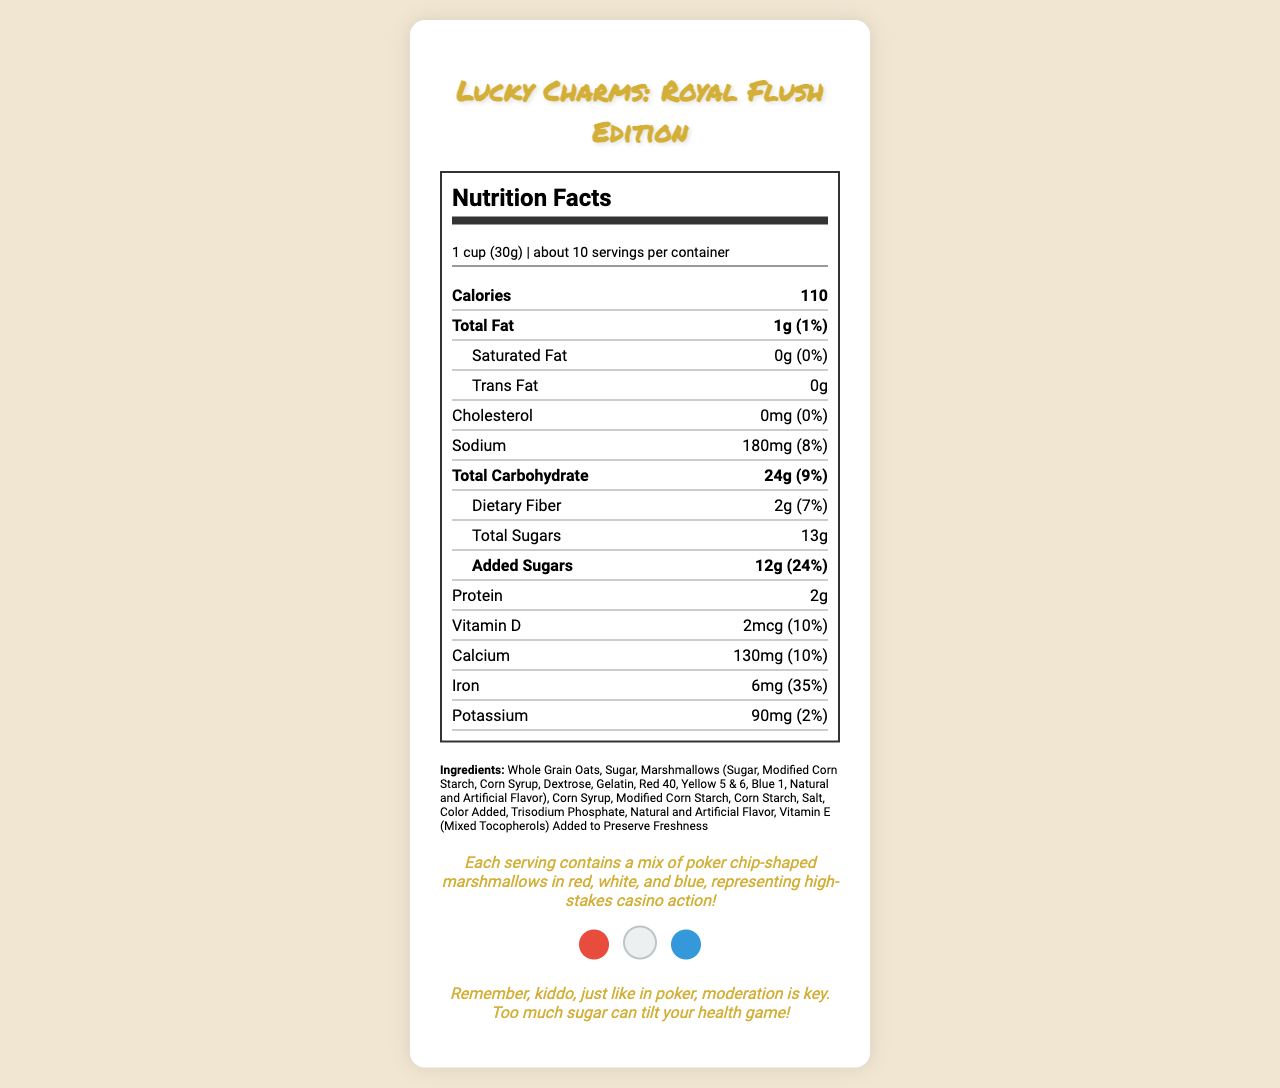what is the serving size of the Lucky Charms: Royal Flush Edition cereal? The serving size is specified near the top of the nutritional label as "1 cup (30g)".
Answer: 1 cup (30g) how much total sugar is in one serving? The total sugar content in one serving is listed in the nutrient section as "Total Sugars: 13g".
Answer: 13g what percentage of the daily value is the added sugars? The amount of added sugars is shown as 12g with a daily value of 24%.
Answer: 24% what are the first three ingredients listed? The ingredient list starts with "Whole Grain Oats," "Sugar," and then "Marshmallows."
Answer: Whole Grain Oats, Sugar, Marshmallows how many calories are in one serving? The calorie count per serving is shown in a bold format as 110 calories.
Answer: 110 how much protein is in one serving? The protein content is listed in the nutrient section as 2g.
Answer: 2g what is the daily value percentage for iron? The daily value percentage for iron is shown as 35%.
Answer: 35% which vitamin is present in 2mcg and what is its daily value percentage? A. Vitamin A B. Vitamin B C. Vitamin D D. Vitamin C Vitamin D is present at 2mcg with a daily value percentage of 10%, as mentioned under the nutrient section.
Answer: C. Vitamin D what is the daily value percentage for dietary fiber? A. 5% B. 7% C. 10% D. 15% The daily value percentage for dietary fiber is shown as 7%.
Answer: B. 7% is there any trans fat in the cereal? The amount of trans fat is specified as "0g".
Answer: No summarize the nutritional information provided for Lucky Charms: Royal Flush Edition cereal. This summary encapsulates the key nutritional details provided in the document.
Answer: The nutrition facts for Lucky Charms: Royal Flush Edition cereal indicate it has a serving size of 1 cup (30g) with 110 calories per serving. It contains 1g of total fat, 180mg of sodium, 24g of total carbohydrates, including 2g of dietary fiber and 13g of total sugars (12g added sugars). It provides 2g of protein. The cereal has various vitamin and mineral contents including 10% Vitamin D, 10% Calcium, 35% Iron, and 2% Potassium. what colors do the poker-chip shaped marshmallows come in? The fun fact section mentions that the marshmallows are shaped like poker chips and come in red, white, and blue.
Answer: Red, White, and Blue how many servings are in one container of the cereal approximately? The top of the nutrition label indicates that there are about 10 servings per container.
Answer: About 10 what percentage daily value of sodium does one serving of the cereal contain? The sodium content in one serving is shown with a daily value of 8%.
Answer: 8% what is the total carbohydrate content in one serving? The total carbohydrate content is listed in the nutrient section as 24g.
Answer: 24g what allergens might be found in this cereal? The allergen information specifies that the cereal contains wheat ingredients and may contain traces of peanuts, almonds, and other tree nuts.
Answer: Wheat ingredients, traces of peanuts, almonds, and other tree nuts what is the "fun fact" related to this cereal? The fun fact section near the end of the document shares this detail about the unique marshmallow shapes and their colors.
Answer: Each serving contains a mix of poker chip-shaped marshmallows in red, white, and blue, representing high-stakes casino action! what wisdom did the grandparent share about consuming this cereal? The grandparent's wisdom is shared as a reminder to consume sugar in moderation.
Answer: Remember, kiddo, just like in poker, moderation is key. Too much sugar can tilt your health game! how much calcium is in a serving and what percentage of the daily value does it represent? The amount of calcium is shown as 130mg, which represents 10% of the daily value.
Answer: 130mg, 10% what is the recommended daily intake of protein for a teenager? The nutrition label does not provide information about the recommended daily intake of protein for a teenager.
Answer: Not enough information 